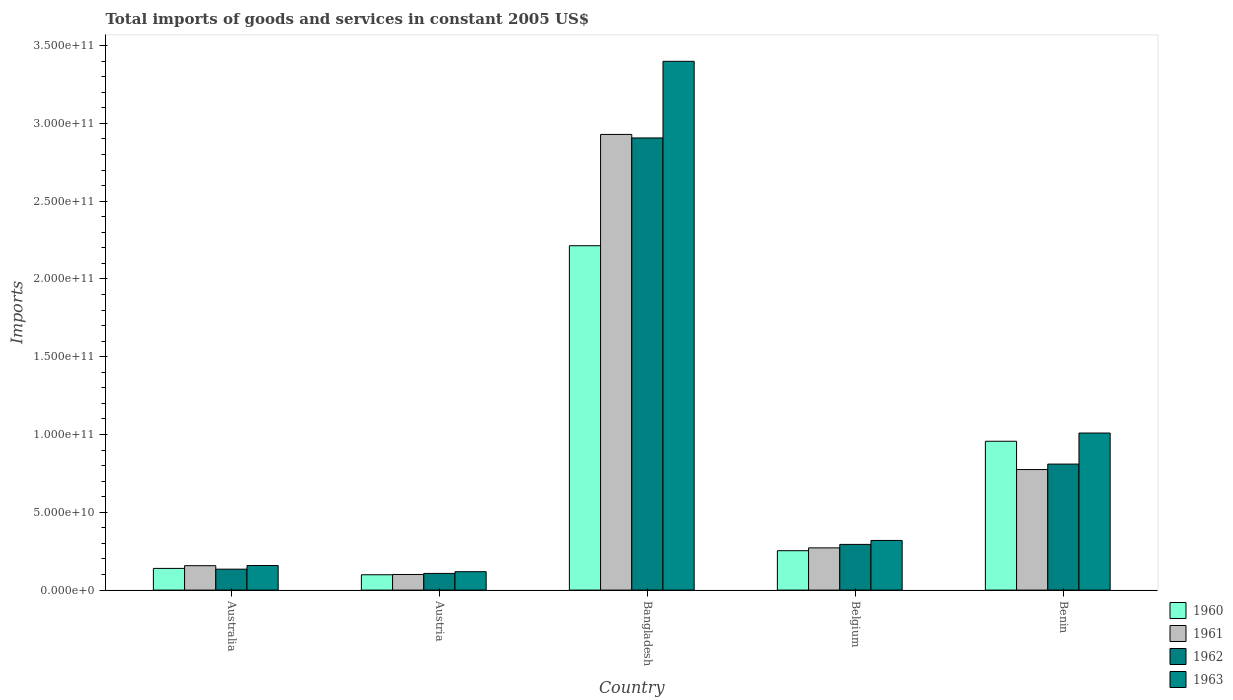How many different coloured bars are there?
Your response must be concise. 4. How many groups of bars are there?
Your answer should be very brief. 5. What is the label of the 2nd group of bars from the left?
Provide a short and direct response. Austria. What is the total imports of goods and services in 1963 in Australia?
Make the answer very short. 1.58e+1. Across all countries, what is the maximum total imports of goods and services in 1962?
Offer a very short reply. 2.91e+11. Across all countries, what is the minimum total imports of goods and services in 1960?
Offer a terse response. 9.86e+09. In which country was the total imports of goods and services in 1961 maximum?
Offer a very short reply. Bangladesh. In which country was the total imports of goods and services in 1960 minimum?
Keep it short and to the point. Austria. What is the total total imports of goods and services in 1960 in the graph?
Provide a succinct answer. 3.66e+11. What is the difference between the total imports of goods and services in 1962 in Austria and that in Bangladesh?
Your answer should be very brief. -2.80e+11. What is the difference between the total imports of goods and services in 1961 in Belgium and the total imports of goods and services in 1962 in Bangladesh?
Make the answer very short. -2.64e+11. What is the average total imports of goods and services in 1960 per country?
Your answer should be very brief. 7.32e+1. What is the difference between the total imports of goods and services of/in 1962 and total imports of goods and services of/in 1960 in Belgium?
Ensure brevity in your answer.  4.05e+09. What is the ratio of the total imports of goods and services in 1963 in Bangladesh to that in Benin?
Offer a terse response. 3.37. What is the difference between the highest and the second highest total imports of goods and services in 1963?
Offer a very short reply. -2.39e+11. What is the difference between the highest and the lowest total imports of goods and services in 1960?
Offer a terse response. 2.12e+11. Is the sum of the total imports of goods and services in 1963 in Australia and Austria greater than the maximum total imports of goods and services in 1962 across all countries?
Ensure brevity in your answer.  No. Is it the case that in every country, the sum of the total imports of goods and services in 1961 and total imports of goods and services in 1962 is greater than the sum of total imports of goods and services in 1963 and total imports of goods and services in 1960?
Your response must be concise. No. What does the 1st bar from the left in Belgium represents?
Your answer should be compact. 1960. What does the 3rd bar from the right in Benin represents?
Provide a succinct answer. 1961. Is it the case that in every country, the sum of the total imports of goods and services in 1960 and total imports of goods and services in 1962 is greater than the total imports of goods and services in 1963?
Provide a succinct answer. Yes. How many bars are there?
Your answer should be compact. 20. How many legend labels are there?
Offer a very short reply. 4. What is the title of the graph?
Make the answer very short. Total imports of goods and services in constant 2005 US$. What is the label or title of the X-axis?
Offer a very short reply. Country. What is the label or title of the Y-axis?
Your answer should be compact. Imports. What is the Imports of 1960 in Australia?
Offer a very short reply. 1.40e+1. What is the Imports of 1961 in Australia?
Your answer should be very brief. 1.57e+1. What is the Imports of 1962 in Australia?
Offer a very short reply. 1.35e+1. What is the Imports of 1963 in Australia?
Your response must be concise. 1.58e+1. What is the Imports in 1960 in Austria?
Your answer should be very brief. 9.86e+09. What is the Imports in 1961 in Austria?
Provide a succinct answer. 1.00e+1. What is the Imports in 1962 in Austria?
Provide a short and direct response. 1.07e+1. What is the Imports of 1963 in Austria?
Your answer should be very brief. 1.18e+1. What is the Imports of 1960 in Bangladesh?
Offer a very short reply. 2.21e+11. What is the Imports of 1961 in Bangladesh?
Provide a succinct answer. 2.93e+11. What is the Imports of 1962 in Bangladesh?
Ensure brevity in your answer.  2.91e+11. What is the Imports of 1963 in Bangladesh?
Provide a short and direct response. 3.40e+11. What is the Imports in 1960 in Belgium?
Your response must be concise. 2.53e+1. What is the Imports of 1961 in Belgium?
Offer a very short reply. 2.72e+1. What is the Imports of 1962 in Belgium?
Make the answer very short. 2.94e+1. What is the Imports in 1963 in Belgium?
Offer a terse response. 3.19e+1. What is the Imports in 1960 in Benin?
Keep it short and to the point. 9.57e+1. What is the Imports in 1961 in Benin?
Your answer should be compact. 7.75e+1. What is the Imports in 1962 in Benin?
Make the answer very short. 8.10e+1. What is the Imports of 1963 in Benin?
Keep it short and to the point. 1.01e+11. Across all countries, what is the maximum Imports of 1960?
Your answer should be very brief. 2.21e+11. Across all countries, what is the maximum Imports of 1961?
Keep it short and to the point. 2.93e+11. Across all countries, what is the maximum Imports in 1962?
Ensure brevity in your answer.  2.91e+11. Across all countries, what is the maximum Imports in 1963?
Offer a terse response. 3.40e+11. Across all countries, what is the minimum Imports in 1960?
Provide a short and direct response. 9.86e+09. Across all countries, what is the minimum Imports in 1961?
Provide a succinct answer. 1.00e+1. Across all countries, what is the minimum Imports in 1962?
Your response must be concise. 1.07e+1. Across all countries, what is the minimum Imports of 1963?
Your answer should be very brief. 1.18e+1. What is the total Imports in 1960 in the graph?
Offer a very short reply. 3.66e+11. What is the total Imports in 1961 in the graph?
Offer a very short reply. 4.23e+11. What is the total Imports of 1962 in the graph?
Ensure brevity in your answer.  4.25e+11. What is the total Imports of 1963 in the graph?
Keep it short and to the point. 5.00e+11. What is the difference between the Imports in 1960 in Australia and that in Austria?
Provide a short and direct response. 4.09e+09. What is the difference between the Imports of 1961 in Australia and that in Austria?
Provide a succinct answer. 5.65e+09. What is the difference between the Imports in 1962 in Australia and that in Austria?
Provide a short and direct response. 2.73e+09. What is the difference between the Imports of 1963 in Australia and that in Austria?
Offer a terse response. 3.96e+09. What is the difference between the Imports of 1960 in Australia and that in Bangladesh?
Give a very brief answer. -2.07e+11. What is the difference between the Imports in 1961 in Australia and that in Bangladesh?
Give a very brief answer. -2.77e+11. What is the difference between the Imports in 1962 in Australia and that in Bangladesh?
Provide a succinct answer. -2.77e+11. What is the difference between the Imports of 1963 in Australia and that in Bangladesh?
Keep it short and to the point. -3.24e+11. What is the difference between the Imports of 1960 in Australia and that in Belgium?
Give a very brief answer. -1.14e+1. What is the difference between the Imports in 1961 in Australia and that in Belgium?
Your answer should be very brief. -1.15e+1. What is the difference between the Imports of 1962 in Australia and that in Belgium?
Make the answer very short. -1.59e+1. What is the difference between the Imports of 1963 in Australia and that in Belgium?
Provide a succinct answer. -1.61e+1. What is the difference between the Imports of 1960 in Australia and that in Benin?
Offer a terse response. -8.17e+1. What is the difference between the Imports of 1961 in Australia and that in Benin?
Your answer should be compact. -6.18e+1. What is the difference between the Imports of 1962 in Australia and that in Benin?
Make the answer very short. -6.76e+1. What is the difference between the Imports in 1963 in Australia and that in Benin?
Your answer should be compact. -8.52e+1. What is the difference between the Imports of 1960 in Austria and that in Bangladesh?
Provide a succinct answer. -2.12e+11. What is the difference between the Imports in 1961 in Austria and that in Bangladesh?
Offer a terse response. -2.83e+11. What is the difference between the Imports of 1962 in Austria and that in Bangladesh?
Give a very brief answer. -2.80e+11. What is the difference between the Imports in 1963 in Austria and that in Bangladesh?
Your answer should be compact. -3.28e+11. What is the difference between the Imports in 1960 in Austria and that in Belgium?
Provide a short and direct response. -1.55e+1. What is the difference between the Imports of 1961 in Austria and that in Belgium?
Ensure brevity in your answer.  -1.71e+1. What is the difference between the Imports in 1962 in Austria and that in Belgium?
Offer a terse response. -1.87e+1. What is the difference between the Imports in 1963 in Austria and that in Belgium?
Keep it short and to the point. -2.01e+1. What is the difference between the Imports of 1960 in Austria and that in Benin?
Provide a short and direct response. -8.58e+1. What is the difference between the Imports of 1961 in Austria and that in Benin?
Keep it short and to the point. -6.74e+1. What is the difference between the Imports of 1962 in Austria and that in Benin?
Offer a terse response. -7.03e+1. What is the difference between the Imports of 1963 in Austria and that in Benin?
Make the answer very short. -8.91e+1. What is the difference between the Imports in 1960 in Bangladesh and that in Belgium?
Ensure brevity in your answer.  1.96e+11. What is the difference between the Imports in 1961 in Bangladesh and that in Belgium?
Offer a terse response. 2.66e+11. What is the difference between the Imports of 1962 in Bangladesh and that in Belgium?
Your answer should be very brief. 2.61e+11. What is the difference between the Imports of 1963 in Bangladesh and that in Belgium?
Provide a short and direct response. 3.08e+11. What is the difference between the Imports of 1960 in Bangladesh and that in Benin?
Make the answer very short. 1.26e+11. What is the difference between the Imports of 1961 in Bangladesh and that in Benin?
Your response must be concise. 2.15e+11. What is the difference between the Imports of 1962 in Bangladesh and that in Benin?
Provide a short and direct response. 2.10e+11. What is the difference between the Imports of 1963 in Bangladesh and that in Benin?
Ensure brevity in your answer.  2.39e+11. What is the difference between the Imports in 1960 in Belgium and that in Benin?
Your answer should be compact. -7.04e+1. What is the difference between the Imports in 1961 in Belgium and that in Benin?
Offer a terse response. -5.03e+1. What is the difference between the Imports of 1962 in Belgium and that in Benin?
Provide a short and direct response. -5.16e+1. What is the difference between the Imports in 1963 in Belgium and that in Benin?
Provide a short and direct response. -6.90e+1. What is the difference between the Imports of 1960 in Australia and the Imports of 1961 in Austria?
Keep it short and to the point. 3.91e+09. What is the difference between the Imports of 1960 in Australia and the Imports of 1962 in Austria?
Your answer should be very brief. 3.22e+09. What is the difference between the Imports in 1960 in Australia and the Imports in 1963 in Austria?
Keep it short and to the point. 2.12e+09. What is the difference between the Imports of 1961 in Australia and the Imports of 1962 in Austria?
Offer a terse response. 4.97e+09. What is the difference between the Imports in 1961 in Australia and the Imports in 1963 in Austria?
Ensure brevity in your answer.  3.87e+09. What is the difference between the Imports of 1962 in Australia and the Imports of 1963 in Austria?
Make the answer very short. 1.63e+09. What is the difference between the Imports of 1960 in Australia and the Imports of 1961 in Bangladesh?
Give a very brief answer. -2.79e+11. What is the difference between the Imports of 1960 in Australia and the Imports of 1962 in Bangladesh?
Give a very brief answer. -2.77e+11. What is the difference between the Imports of 1960 in Australia and the Imports of 1963 in Bangladesh?
Your answer should be compact. -3.26e+11. What is the difference between the Imports in 1961 in Australia and the Imports in 1962 in Bangladesh?
Give a very brief answer. -2.75e+11. What is the difference between the Imports of 1961 in Australia and the Imports of 1963 in Bangladesh?
Provide a succinct answer. -3.24e+11. What is the difference between the Imports in 1962 in Australia and the Imports in 1963 in Bangladesh?
Keep it short and to the point. -3.26e+11. What is the difference between the Imports of 1960 in Australia and the Imports of 1961 in Belgium?
Keep it short and to the point. -1.32e+1. What is the difference between the Imports of 1960 in Australia and the Imports of 1962 in Belgium?
Your answer should be very brief. -1.54e+1. What is the difference between the Imports in 1960 in Australia and the Imports in 1963 in Belgium?
Keep it short and to the point. -1.80e+1. What is the difference between the Imports in 1961 in Australia and the Imports in 1962 in Belgium?
Make the answer very short. -1.37e+1. What is the difference between the Imports in 1961 in Australia and the Imports in 1963 in Belgium?
Make the answer very short. -1.62e+1. What is the difference between the Imports of 1962 in Australia and the Imports of 1963 in Belgium?
Make the answer very short. -1.85e+1. What is the difference between the Imports of 1960 in Australia and the Imports of 1961 in Benin?
Provide a succinct answer. -6.35e+1. What is the difference between the Imports in 1960 in Australia and the Imports in 1962 in Benin?
Offer a very short reply. -6.71e+1. What is the difference between the Imports of 1960 in Australia and the Imports of 1963 in Benin?
Provide a succinct answer. -8.70e+1. What is the difference between the Imports of 1961 in Australia and the Imports of 1962 in Benin?
Your answer should be compact. -6.53e+1. What is the difference between the Imports of 1961 in Australia and the Imports of 1963 in Benin?
Provide a short and direct response. -8.53e+1. What is the difference between the Imports in 1962 in Australia and the Imports in 1963 in Benin?
Ensure brevity in your answer.  -8.75e+1. What is the difference between the Imports in 1960 in Austria and the Imports in 1961 in Bangladesh?
Your response must be concise. -2.83e+11. What is the difference between the Imports in 1960 in Austria and the Imports in 1962 in Bangladesh?
Give a very brief answer. -2.81e+11. What is the difference between the Imports in 1960 in Austria and the Imports in 1963 in Bangladesh?
Your answer should be very brief. -3.30e+11. What is the difference between the Imports of 1961 in Austria and the Imports of 1962 in Bangladesh?
Offer a very short reply. -2.81e+11. What is the difference between the Imports in 1961 in Austria and the Imports in 1963 in Bangladesh?
Ensure brevity in your answer.  -3.30e+11. What is the difference between the Imports in 1962 in Austria and the Imports in 1963 in Bangladesh?
Make the answer very short. -3.29e+11. What is the difference between the Imports of 1960 in Austria and the Imports of 1961 in Belgium?
Your answer should be very brief. -1.73e+1. What is the difference between the Imports of 1960 in Austria and the Imports of 1962 in Belgium?
Provide a short and direct response. -1.95e+1. What is the difference between the Imports of 1960 in Austria and the Imports of 1963 in Belgium?
Your response must be concise. -2.21e+1. What is the difference between the Imports of 1961 in Austria and the Imports of 1962 in Belgium?
Provide a succinct answer. -1.93e+1. What is the difference between the Imports in 1961 in Austria and the Imports in 1963 in Belgium?
Offer a very short reply. -2.19e+1. What is the difference between the Imports in 1962 in Austria and the Imports in 1963 in Belgium?
Your response must be concise. -2.12e+1. What is the difference between the Imports of 1960 in Austria and the Imports of 1961 in Benin?
Your answer should be very brief. -6.76e+1. What is the difference between the Imports in 1960 in Austria and the Imports in 1962 in Benin?
Your response must be concise. -7.12e+1. What is the difference between the Imports in 1960 in Austria and the Imports in 1963 in Benin?
Provide a succinct answer. -9.11e+1. What is the difference between the Imports of 1961 in Austria and the Imports of 1962 in Benin?
Provide a short and direct response. -7.10e+1. What is the difference between the Imports in 1961 in Austria and the Imports in 1963 in Benin?
Your response must be concise. -9.09e+1. What is the difference between the Imports in 1962 in Austria and the Imports in 1963 in Benin?
Keep it short and to the point. -9.02e+1. What is the difference between the Imports of 1960 in Bangladesh and the Imports of 1961 in Belgium?
Provide a short and direct response. 1.94e+11. What is the difference between the Imports in 1960 in Bangladesh and the Imports in 1962 in Belgium?
Your answer should be compact. 1.92e+11. What is the difference between the Imports in 1960 in Bangladesh and the Imports in 1963 in Belgium?
Ensure brevity in your answer.  1.89e+11. What is the difference between the Imports of 1961 in Bangladesh and the Imports of 1962 in Belgium?
Make the answer very short. 2.64e+11. What is the difference between the Imports of 1961 in Bangladesh and the Imports of 1963 in Belgium?
Your response must be concise. 2.61e+11. What is the difference between the Imports in 1962 in Bangladesh and the Imports in 1963 in Belgium?
Provide a succinct answer. 2.59e+11. What is the difference between the Imports in 1960 in Bangladesh and the Imports in 1961 in Benin?
Your response must be concise. 1.44e+11. What is the difference between the Imports in 1960 in Bangladesh and the Imports in 1962 in Benin?
Your answer should be very brief. 1.40e+11. What is the difference between the Imports of 1960 in Bangladesh and the Imports of 1963 in Benin?
Provide a short and direct response. 1.20e+11. What is the difference between the Imports of 1961 in Bangladesh and the Imports of 1962 in Benin?
Offer a terse response. 2.12e+11. What is the difference between the Imports of 1961 in Bangladesh and the Imports of 1963 in Benin?
Give a very brief answer. 1.92e+11. What is the difference between the Imports of 1962 in Bangladesh and the Imports of 1963 in Benin?
Offer a very short reply. 1.90e+11. What is the difference between the Imports in 1960 in Belgium and the Imports in 1961 in Benin?
Offer a terse response. -5.22e+1. What is the difference between the Imports of 1960 in Belgium and the Imports of 1962 in Benin?
Give a very brief answer. -5.57e+1. What is the difference between the Imports of 1960 in Belgium and the Imports of 1963 in Benin?
Ensure brevity in your answer.  -7.56e+1. What is the difference between the Imports of 1961 in Belgium and the Imports of 1962 in Benin?
Your answer should be compact. -5.39e+1. What is the difference between the Imports of 1961 in Belgium and the Imports of 1963 in Benin?
Your response must be concise. -7.38e+1. What is the difference between the Imports in 1962 in Belgium and the Imports in 1963 in Benin?
Give a very brief answer. -7.16e+1. What is the average Imports of 1960 per country?
Your answer should be compact. 7.32e+1. What is the average Imports of 1961 per country?
Your answer should be very brief. 8.47e+1. What is the average Imports of 1962 per country?
Give a very brief answer. 8.51e+1. What is the average Imports in 1963 per country?
Provide a short and direct response. 1.00e+11. What is the difference between the Imports of 1960 and Imports of 1961 in Australia?
Your response must be concise. -1.75e+09. What is the difference between the Imports of 1960 and Imports of 1962 in Australia?
Ensure brevity in your answer.  4.92e+08. What is the difference between the Imports in 1960 and Imports in 1963 in Australia?
Provide a short and direct response. -1.84e+09. What is the difference between the Imports of 1961 and Imports of 1962 in Australia?
Keep it short and to the point. 2.24e+09. What is the difference between the Imports of 1961 and Imports of 1963 in Australia?
Your answer should be very brief. -9.40e+07. What is the difference between the Imports of 1962 and Imports of 1963 in Australia?
Offer a very short reply. -2.33e+09. What is the difference between the Imports in 1960 and Imports in 1961 in Austria?
Your answer should be compact. -1.83e+08. What is the difference between the Imports of 1960 and Imports of 1962 in Austria?
Your answer should be compact. -8.69e+08. What is the difference between the Imports in 1960 and Imports in 1963 in Austria?
Offer a very short reply. -1.97e+09. What is the difference between the Imports in 1961 and Imports in 1962 in Austria?
Offer a very short reply. -6.86e+08. What is the difference between the Imports of 1961 and Imports of 1963 in Austria?
Offer a very short reply. -1.78e+09. What is the difference between the Imports in 1962 and Imports in 1963 in Austria?
Provide a succinct answer. -1.10e+09. What is the difference between the Imports in 1960 and Imports in 1961 in Bangladesh?
Your response must be concise. -7.15e+1. What is the difference between the Imports in 1960 and Imports in 1962 in Bangladesh?
Make the answer very short. -6.93e+1. What is the difference between the Imports in 1960 and Imports in 1963 in Bangladesh?
Keep it short and to the point. -1.19e+11. What is the difference between the Imports of 1961 and Imports of 1962 in Bangladesh?
Provide a succinct answer. 2.26e+09. What is the difference between the Imports in 1961 and Imports in 1963 in Bangladesh?
Ensure brevity in your answer.  -4.70e+1. What is the difference between the Imports in 1962 and Imports in 1963 in Bangladesh?
Provide a short and direct response. -4.93e+1. What is the difference between the Imports in 1960 and Imports in 1961 in Belgium?
Your response must be concise. -1.82e+09. What is the difference between the Imports in 1960 and Imports in 1962 in Belgium?
Keep it short and to the point. -4.05e+09. What is the difference between the Imports in 1960 and Imports in 1963 in Belgium?
Offer a terse response. -6.59e+09. What is the difference between the Imports in 1961 and Imports in 1962 in Belgium?
Your answer should be compact. -2.23e+09. What is the difference between the Imports in 1961 and Imports in 1963 in Belgium?
Make the answer very short. -4.77e+09. What is the difference between the Imports of 1962 and Imports of 1963 in Belgium?
Your answer should be compact. -2.54e+09. What is the difference between the Imports of 1960 and Imports of 1961 in Benin?
Give a very brief answer. 1.82e+1. What is the difference between the Imports of 1960 and Imports of 1962 in Benin?
Provide a succinct answer. 1.47e+1. What is the difference between the Imports in 1960 and Imports in 1963 in Benin?
Provide a short and direct response. -5.28e+09. What is the difference between the Imports of 1961 and Imports of 1962 in Benin?
Your response must be concise. -3.52e+09. What is the difference between the Imports of 1961 and Imports of 1963 in Benin?
Offer a very short reply. -2.35e+1. What is the difference between the Imports of 1962 and Imports of 1963 in Benin?
Your answer should be very brief. -2.00e+1. What is the ratio of the Imports of 1960 in Australia to that in Austria?
Keep it short and to the point. 1.41. What is the ratio of the Imports of 1961 in Australia to that in Austria?
Keep it short and to the point. 1.56. What is the ratio of the Imports of 1962 in Australia to that in Austria?
Provide a short and direct response. 1.25. What is the ratio of the Imports of 1963 in Australia to that in Austria?
Make the answer very short. 1.33. What is the ratio of the Imports in 1960 in Australia to that in Bangladesh?
Your answer should be very brief. 0.06. What is the ratio of the Imports in 1961 in Australia to that in Bangladesh?
Ensure brevity in your answer.  0.05. What is the ratio of the Imports in 1962 in Australia to that in Bangladesh?
Offer a terse response. 0.05. What is the ratio of the Imports in 1963 in Australia to that in Bangladesh?
Provide a short and direct response. 0.05. What is the ratio of the Imports of 1960 in Australia to that in Belgium?
Provide a succinct answer. 0.55. What is the ratio of the Imports of 1961 in Australia to that in Belgium?
Ensure brevity in your answer.  0.58. What is the ratio of the Imports in 1962 in Australia to that in Belgium?
Offer a terse response. 0.46. What is the ratio of the Imports of 1963 in Australia to that in Belgium?
Your answer should be compact. 0.49. What is the ratio of the Imports in 1960 in Australia to that in Benin?
Your answer should be compact. 0.15. What is the ratio of the Imports in 1961 in Australia to that in Benin?
Offer a terse response. 0.2. What is the ratio of the Imports of 1962 in Australia to that in Benin?
Ensure brevity in your answer.  0.17. What is the ratio of the Imports in 1963 in Australia to that in Benin?
Your answer should be very brief. 0.16. What is the ratio of the Imports of 1960 in Austria to that in Bangladesh?
Offer a very short reply. 0.04. What is the ratio of the Imports of 1961 in Austria to that in Bangladesh?
Ensure brevity in your answer.  0.03. What is the ratio of the Imports of 1962 in Austria to that in Bangladesh?
Your answer should be very brief. 0.04. What is the ratio of the Imports in 1963 in Austria to that in Bangladesh?
Provide a short and direct response. 0.03. What is the ratio of the Imports of 1960 in Austria to that in Belgium?
Your response must be concise. 0.39. What is the ratio of the Imports in 1961 in Austria to that in Belgium?
Provide a succinct answer. 0.37. What is the ratio of the Imports of 1962 in Austria to that in Belgium?
Offer a terse response. 0.37. What is the ratio of the Imports in 1963 in Austria to that in Belgium?
Offer a very short reply. 0.37. What is the ratio of the Imports in 1960 in Austria to that in Benin?
Ensure brevity in your answer.  0.1. What is the ratio of the Imports in 1961 in Austria to that in Benin?
Ensure brevity in your answer.  0.13. What is the ratio of the Imports of 1962 in Austria to that in Benin?
Offer a terse response. 0.13. What is the ratio of the Imports of 1963 in Austria to that in Benin?
Offer a very short reply. 0.12. What is the ratio of the Imports in 1960 in Bangladesh to that in Belgium?
Give a very brief answer. 8.74. What is the ratio of the Imports in 1961 in Bangladesh to that in Belgium?
Give a very brief answer. 10.79. What is the ratio of the Imports in 1962 in Bangladesh to that in Belgium?
Your answer should be very brief. 9.89. What is the ratio of the Imports of 1963 in Bangladesh to that in Belgium?
Ensure brevity in your answer.  10.65. What is the ratio of the Imports of 1960 in Bangladesh to that in Benin?
Offer a very short reply. 2.31. What is the ratio of the Imports in 1961 in Bangladesh to that in Benin?
Your response must be concise. 3.78. What is the ratio of the Imports of 1962 in Bangladesh to that in Benin?
Offer a terse response. 3.59. What is the ratio of the Imports of 1963 in Bangladesh to that in Benin?
Keep it short and to the point. 3.37. What is the ratio of the Imports in 1960 in Belgium to that in Benin?
Your answer should be compact. 0.26. What is the ratio of the Imports of 1961 in Belgium to that in Benin?
Ensure brevity in your answer.  0.35. What is the ratio of the Imports of 1962 in Belgium to that in Benin?
Ensure brevity in your answer.  0.36. What is the ratio of the Imports of 1963 in Belgium to that in Benin?
Give a very brief answer. 0.32. What is the difference between the highest and the second highest Imports in 1960?
Your answer should be compact. 1.26e+11. What is the difference between the highest and the second highest Imports in 1961?
Provide a succinct answer. 2.15e+11. What is the difference between the highest and the second highest Imports in 1962?
Your answer should be very brief. 2.10e+11. What is the difference between the highest and the second highest Imports in 1963?
Your response must be concise. 2.39e+11. What is the difference between the highest and the lowest Imports in 1960?
Provide a short and direct response. 2.12e+11. What is the difference between the highest and the lowest Imports in 1961?
Offer a very short reply. 2.83e+11. What is the difference between the highest and the lowest Imports in 1962?
Provide a short and direct response. 2.80e+11. What is the difference between the highest and the lowest Imports of 1963?
Provide a succinct answer. 3.28e+11. 